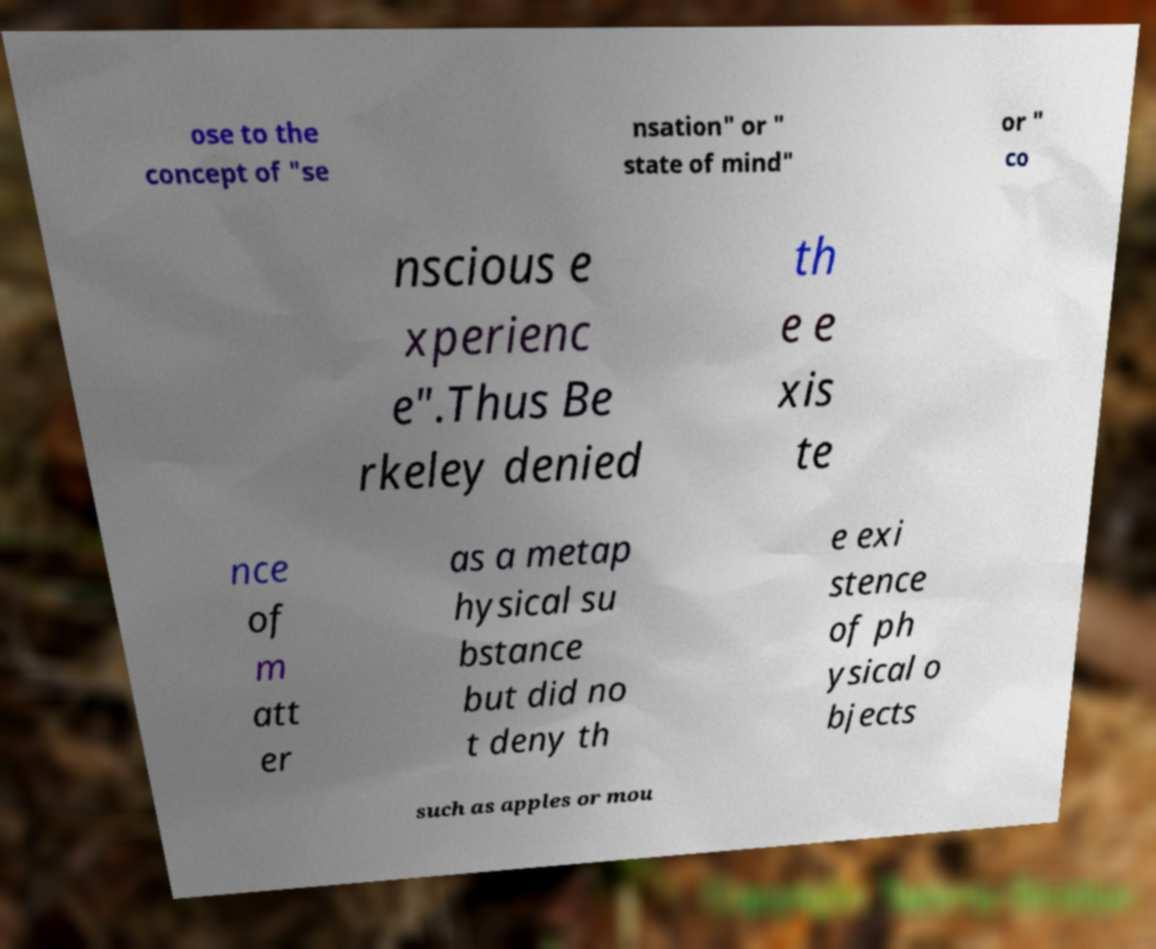Please identify and transcribe the text found in this image. ose to the concept of "se nsation" or " state of mind" or " co nscious e xperienc e".Thus Be rkeley denied th e e xis te nce of m att er as a metap hysical su bstance but did no t deny th e exi stence of ph ysical o bjects such as apples or mou 